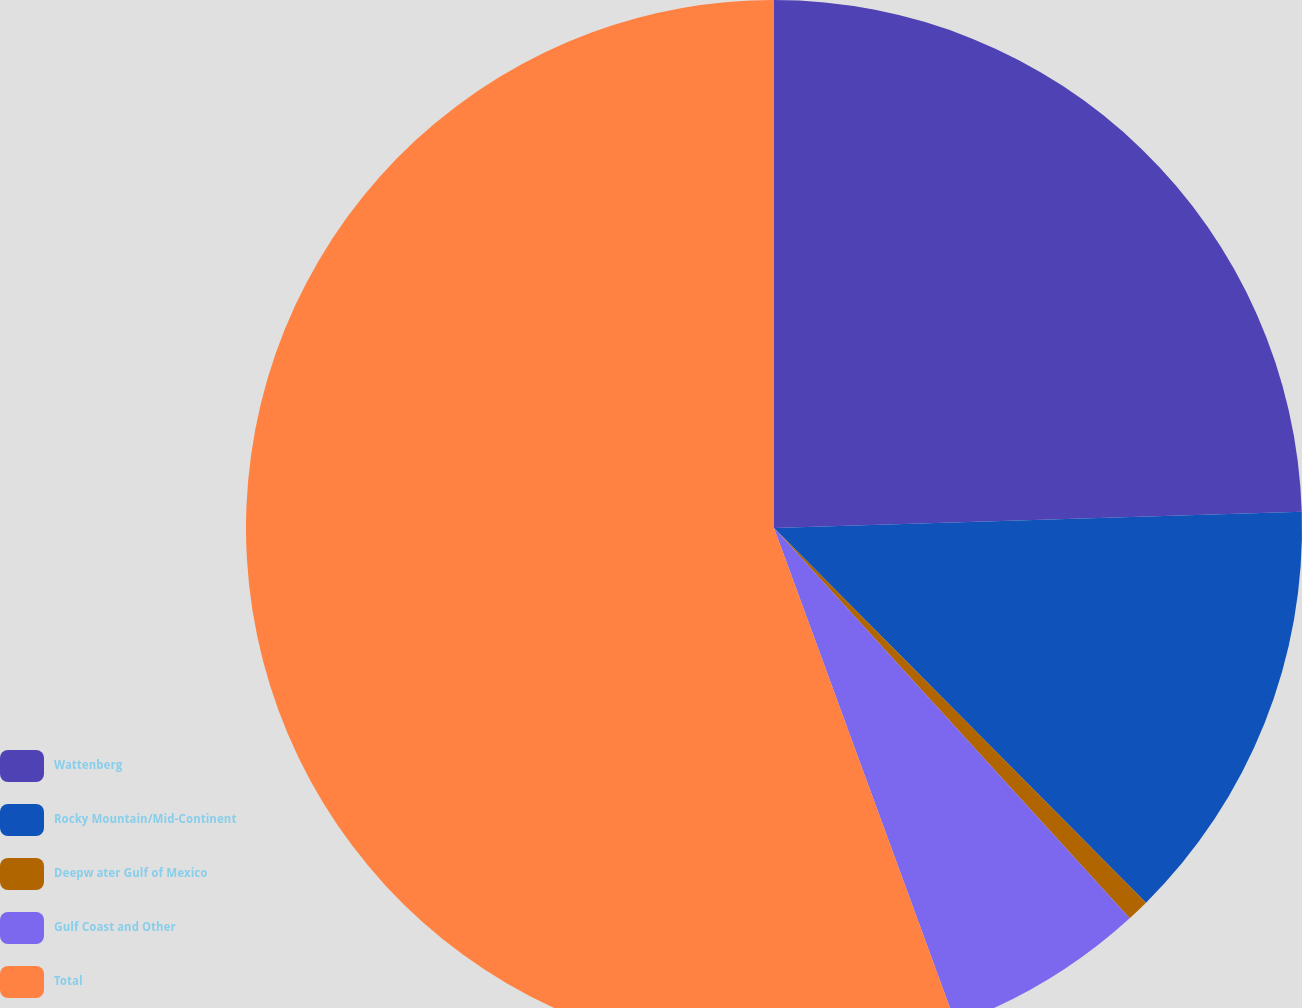Convert chart. <chart><loc_0><loc_0><loc_500><loc_500><pie_chart><fcel>Wattenberg<fcel>Rocky Mountain/Mid-Continent<fcel>Deepw ater Gulf of Mexico<fcel>Gulf Coast and Other<fcel>Total<nl><fcel>24.51%<fcel>13.05%<fcel>0.68%<fcel>6.17%<fcel>55.6%<nl></chart> 